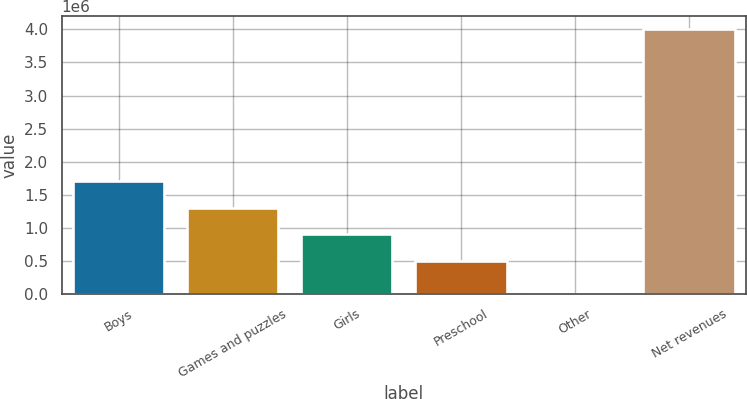Convert chart to OTSL. <chart><loc_0><loc_0><loc_500><loc_500><bar_chart><fcel>Boys<fcel>Games and puzzles<fcel>Girls<fcel>Preschool<fcel>Other<fcel>Net revenues<nl><fcel>1.71003e+06<fcel>1.30988e+06<fcel>909724<fcel>509570<fcel>624<fcel>4.00216e+06<nl></chart> 